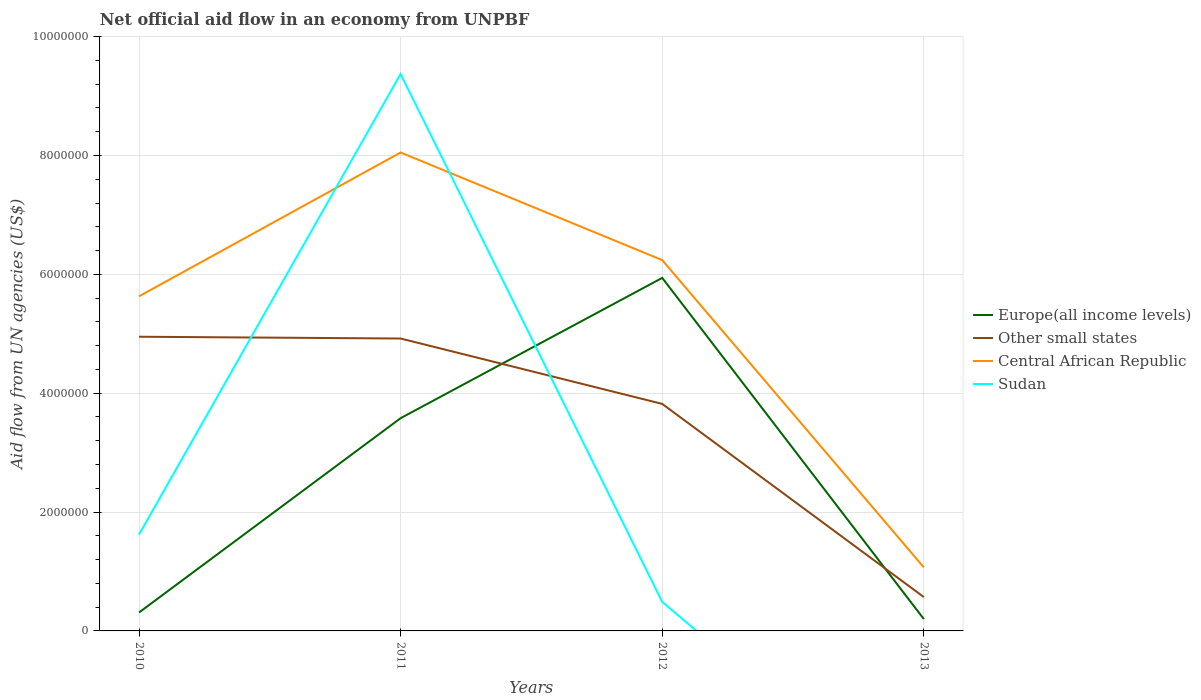Is the number of lines equal to the number of legend labels?
Ensure brevity in your answer.  No. What is the total net official aid flow in Other small states in the graph?
Ensure brevity in your answer.  1.13e+06. What is the difference between the highest and the second highest net official aid flow in Sudan?
Ensure brevity in your answer.  9.37e+06. What is the difference between the highest and the lowest net official aid flow in Other small states?
Offer a terse response. 3. Is the net official aid flow in Europe(all income levels) strictly greater than the net official aid flow in Sudan over the years?
Offer a terse response. No. Are the values on the major ticks of Y-axis written in scientific E-notation?
Give a very brief answer. No. Where does the legend appear in the graph?
Ensure brevity in your answer.  Center right. How many legend labels are there?
Make the answer very short. 4. What is the title of the graph?
Offer a terse response. Net official aid flow in an economy from UNPBF. Does "Russian Federation" appear as one of the legend labels in the graph?
Provide a succinct answer. No. What is the label or title of the Y-axis?
Provide a short and direct response. Aid flow from UN agencies (US$). What is the Aid flow from UN agencies (US$) of Europe(all income levels) in 2010?
Give a very brief answer. 3.10e+05. What is the Aid flow from UN agencies (US$) in Other small states in 2010?
Keep it short and to the point. 4.95e+06. What is the Aid flow from UN agencies (US$) of Central African Republic in 2010?
Offer a very short reply. 5.63e+06. What is the Aid flow from UN agencies (US$) of Sudan in 2010?
Offer a terse response. 1.62e+06. What is the Aid flow from UN agencies (US$) of Europe(all income levels) in 2011?
Provide a short and direct response. 3.58e+06. What is the Aid flow from UN agencies (US$) in Other small states in 2011?
Your answer should be compact. 4.92e+06. What is the Aid flow from UN agencies (US$) of Central African Republic in 2011?
Offer a very short reply. 8.05e+06. What is the Aid flow from UN agencies (US$) in Sudan in 2011?
Your response must be concise. 9.37e+06. What is the Aid flow from UN agencies (US$) of Europe(all income levels) in 2012?
Your response must be concise. 5.94e+06. What is the Aid flow from UN agencies (US$) of Other small states in 2012?
Provide a short and direct response. 3.82e+06. What is the Aid flow from UN agencies (US$) of Central African Republic in 2012?
Provide a short and direct response. 6.24e+06. What is the Aid flow from UN agencies (US$) in Sudan in 2012?
Keep it short and to the point. 4.90e+05. What is the Aid flow from UN agencies (US$) in Other small states in 2013?
Offer a very short reply. 5.70e+05. What is the Aid flow from UN agencies (US$) of Central African Republic in 2013?
Offer a terse response. 1.07e+06. What is the Aid flow from UN agencies (US$) in Sudan in 2013?
Your answer should be compact. 0. Across all years, what is the maximum Aid flow from UN agencies (US$) of Europe(all income levels)?
Your response must be concise. 5.94e+06. Across all years, what is the maximum Aid flow from UN agencies (US$) of Other small states?
Make the answer very short. 4.95e+06. Across all years, what is the maximum Aid flow from UN agencies (US$) in Central African Republic?
Your answer should be very brief. 8.05e+06. Across all years, what is the maximum Aid flow from UN agencies (US$) in Sudan?
Keep it short and to the point. 9.37e+06. Across all years, what is the minimum Aid flow from UN agencies (US$) of Europe(all income levels)?
Offer a very short reply. 2.00e+05. Across all years, what is the minimum Aid flow from UN agencies (US$) of Other small states?
Keep it short and to the point. 5.70e+05. Across all years, what is the minimum Aid flow from UN agencies (US$) in Central African Republic?
Keep it short and to the point. 1.07e+06. Across all years, what is the minimum Aid flow from UN agencies (US$) in Sudan?
Your answer should be very brief. 0. What is the total Aid flow from UN agencies (US$) of Europe(all income levels) in the graph?
Give a very brief answer. 1.00e+07. What is the total Aid flow from UN agencies (US$) in Other small states in the graph?
Your answer should be very brief. 1.43e+07. What is the total Aid flow from UN agencies (US$) of Central African Republic in the graph?
Give a very brief answer. 2.10e+07. What is the total Aid flow from UN agencies (US$) in Sudan in the graph?
Make the answer very short. 1.15e+07. What is the difference between the Aid flow from UN agencies (US$) of Europe(all income levels) in 2010 and that in 2011?
Your response must be concise. -3.27e+06. What is the difference between the Aid flow from UN agencies (US$) of Other small states in 2010 and that in 2011?
Offer a terse response. 3.00e+04. What is the difference between the Aid flow from UN agencies (US$) of Central African Republic in 2010 and that in 2011?
Offer a terse response. -2.42e+06. What is the difference between the Aid flow from UN agencies (US$) in Sudan in 2010 and that in 2011?
Your response must be concise. -7.75e+06. What is the difference between the Aid flow from UN agencies (US$) in Europe(all income levels) in 2010 and that in 2012?
Offer a very short reply. -5.63e+06. What is the difference between the Aid flow from UN agencies (US$) of Other small states in 2010 and that in 2012?
Ensure brevity in your answer.  1.13e+06. What is the difference between the Aid flow from UN agencies (US$) of Central African Republic in 2010 and that in 2012?
Make the answer very short. -6.10e+05. What is the difference between the Aid flow from UN agencies (US$) of Sudan in 2010 and that in 2012?
Provide a succinct answer. 1.13e+06. What is the difference between the Aid flow from UN agencies (US$) in Other small states in 2010 and that in 2013?
Make the answer very short. 4.38e+06. What is the difference between the Aid flow from UN agencies (US$) in Central African Republic in 2010 and that in 2013?
Ensure brevity in your answer.  4.56e+06. What is the difference between the Aid flow from UN agencies (US$) of Europe(all income levels) in 2011 and that in 2012?
Provide a short and direct response. -2.36e+06. What is the difference between the Aid flow from UN agencies (US$) in Other small states in 2011 and that in 2012?
Your response must be concise. 1.10e+06. What is the difference between the Aid flow from UN agencies (US$) of Central African Republic in 2011 and that in 2012?
Give a very brief answer. 1.81e+06. What is the difference between the Aid flow from UN agencies (US$) in Sudan in 2011 and that in 2012?
Your response must be concise. 8.88e+06. What is the difference between the Aid flow from UN agencies (US$) in Europe(all income levels) in 2011 and that in 2013?
Make the answer very short. 3.38e+06. What is the difference between the Aid flow from UN agencies (US$) in Other small states in 2011 and that in 2013?
Make the answer very short. 4.35e+06. What is the difference between the Aid flow from UN agencies (US$) in Central African Republic in 2011 and that in 2013?
Your answer should be compact. 6.98e+06. What is the difference between the Aid flow from UN agencies (US$) of Europe(all income levels) in 2012 and that in 2013?
Ensure brevity in your answer.  5.74e+06. What is the difference between the Aid flow from UN agencies (US$) in Other small states in 2012 and that in 2013?
Your response must be concise. 3.25e+06. What is the difference between the Aid flow from UN agencies (US$) in Central African Republic in 2012 and that in 2013?
Your answer should be compact. 5.17e+06. What is the difference between the Aid flow from UN agencies (US$) of Europe(all income levels) in 2010 and the Aid flow from UN agencies (US$) of Other small states in 2011?
Your answer should be compact. -4.61e+06. What is the difference between the Aid flow from UN agencies (US$) of Europe(all income levels) in 2010 and the Aid flow from UN agencies (US$) of Central African Republic in 2011?
Your answer should be very brief. -7.74e+06. What is the difference between the Aid flow from UN agencies (US$) in Europe(all income levels) in 2010 and the Aid flow from UN agencies (US$) in Sudan in 2011?
Your response must be concise. -9.06e+06. What is the difference between the Aid flow from UN agencies (US$) of Other small states in 2010 and the Aid flow from UN agencies (US$) of Central African Republic in 2011?
Provide a short and direct response. -3.10e+06. What is the difference between the Aid flow from UN agencies (US$) in Other small states in 2010 and the Aid flow from UN agencies (US$) in Sudan in 2011?
Keep it short and to the point. -4.42e+06. What is the difference between the Aid flow from UN agencies (US$) in Central African Republic in 2010 and the Aid flow from UN agencies (US$) in Sudan in 2011?
Ensure brevity in your answer.  -3.74e+06. What is the difference between the Aid flow from UN agencies (US$) of Europe(all income levels) in 2010 and the Aid flow from UN agencies (US$) of Other small states in 2012?
Provide a succinct answer. -3.51e+06. What is the difference between the Aid flow from UN agencies (US$) in Europe(all income levels) in 2010 and the Aid flow from UN agencies (US$) in Central African Republic in 2012?
Your answer should be very brief. -5.93e+06. What is the difference between the Aid flow from UN agencies (US$) of Europe(all income levels) in 2010 and the Aid flow from UN agencies (US$) of Sudan in 2012?
Keep it short and to the point. -1.80e+05. What is the difference between the Aid flow from UN agencies (US$) of Other small states in 2010 and the Aid flow from UN agencies (US$) of Central African Republic in 2012?
Keep it short and to the point. -1.29e+06. What is the difference between the Aid flow from UN agencies (US$) of Other small states in 2010 and the Aid flow from UN agencies (US$) of Sudan in 2012?
Your answer should be very brief. 4.46e+06. What is the difference between the Aid flow from UN agencies (US$) of Central African Republic in 2010 and the Aid flow from UN agencies (US$) of Sudan in 2012?
Provide a succinct answer. 5.14e+06. What is the difference between the Aid flow from UN agencies (US$) of Europe(all income levels) in 2010 and the Aid flow from UN agencies (US$) of Central African Republic in 2013?
Provide a short and direct response. -7.60e+05. What is the difference between the Aid flow from UN agencies (US$) of Other small states in 2010 and the Aid flow from UN agencies (US$) of Central African Republic in 2013?
Your response must be concise. 3.88e+06. What is the difference between the Aid flow from UN agencies (US$) in Europe(all income levels) in 2011 and the Aid flow from UN agencies (US$) in Central African Republic in 2012?
Your response must be concise. -2.66e+06. What is the difference between the Aid flow from UN agencies (US$) of Europe(all income levels) in 2011 and the Aid flow from UN agencies (US$) of Sudan in 2012?
Ensure brevity in your answer.  3.09e+06. What is the difference between the Aid flow from UN agencies (US$) of Other small states in 2011 and the Aid flow from UN agencies (US$) of Central African Republic in 2012?
Offer a terse response. -1.32e+06. What is the difference between the Aid flow from UN agencies (US$) in Other small states in 2011 and the Aid flow from UN agencies (US$) in Sudan in 2012?
Your answer should be very brief. 4.43e+06. What is the difference between the Aid flow from UN agencies (US$) in Central African Republic in 2011 and the Aid flow from UN agencies (US$) in Sudan in 2012?
Keep it short and to the point. 7.56e+06. What is the difference between the Aid flow from UN agencies (US$) of Europe(all income levels) in 2011 and the Aid flow from UN agencies (US$) of Other small states in 2013?
Offer a very short reply. 3.01e+06. What is the difference between the Aid flow from UN agencies (US$) of Europe(all income levels) in 2011 and the Aid flow from UN agencies (US$) of Central African Republic in 2013?
Make the answer very short. 2.51e+06. What is the difference between the Aid flow from UN agencies (US$) in Other small states in 2011 and the Aid flow from UN agencies (US$) in Central African Republic in 2013?
Your response must be concise. 3.85e+06. What is the difference between the Aid flow from UN agencies (US$) of Europe(all income levels) in 2012 and the Aid flow from UN agencies (US$) of Other small states in 2013?
Your response must be concise. 5.37e+06. What is the difference between the Aid flow from UN agencies (US$) of Europe(all income levels) in 2012 and the Aid flow from UN agencies (US$) of Central African Republic in 2013?
Offer a very short reply. 4.87e+06. What is the difference between the Aid flow from UN agencies (US$) in Other small states in 2012 and the Aid flow from UN agencies (US$) in Central African Republic in 2013?
Keep it short and to the point. 2.75e+06. What is the average Aid flow from UN agencies (US$) of Europe(all income levels) per year?
Provide a succinct answer. 2.51e+06. What is the average Aid flow from UN agencies (US$) of Other small states per year?
Your answer should be compact. 3.56e+06. What is the average Aid flow from UN agencies (US$) in Central African Republic per year?
Provide a succinct answer. 5.25e+06. What is the average Aid flow from UN agencies (US$) in Sudan per year?
Give a very brief answer. 2.87e+06. In the year 2010, what is the difference between the Aid flow from UN agencies (US$) of Europe(all income levels) and Aid flow from UN agencies (US$) of Other small states?
Make the answer very short. -4.64e+06. In the year 2010, what is the difference between the Aid flow from UN agencies (US$) in Europe(all income levels) and Aid flow from UN agencies (US$) in Central African Republic?
Your answer should be very brief. -5.32e+06. In the year 2010, what is the difference between the Aid flow from UN agencies (US$) of Europe(all income levels) and Aid flow from UN agencies (US$) of Sudan?
Offer a terse response. -1.31e+06. In the year 2010, what is the difference between the Aid flow from UN agencies (US$) in Other small states and Aid flow from UN agencies (US$) in Central African Republic?
Your answer should be compact. -6.80e+05. In the year 2010, what is the difference between the Aid flow from UN agencies (US$) in Other small states and Aid flow from UN agencies (US$) in Sudan?
Provide a succinct answer. 3.33e+06. In the year 2010, what is the difference between the Aid flow from UN agencies (US$) of Central African Republic and Aid flow from UN agencies (US$) of Sudan?
Offer a terse response. 4.01e+06. In the year 2011, what is the difference between the Aid flow from UN agencies (US$) of Europe(all income levels) and Aid flow from UN agencies (US$) of Other small states?
Offer a very short reply. -1.34e+06. In the year 2011, what is the difference between the Aid flow from UN agencies (US$) in Europe(all income levels) and Aid flow from UN agencies (US$) in Central African Republic?
Give a very brief answer. -4.47e+06. In the year 2011, what is the difference between the Aid flow from UN agencies (US$) in Europe(all income levels) and Aid flow from UN agencies (US$) in Sudan?
Ensure brevity in your answer.  -5.79e+06. In the year 2011, what is the difference between the Aid flow from UN agencies (US$) in Other small states and Aid flow from UN agencies (US$) in Central African Republic?
Give a very brief answer. -3.13e+06. In the year 2011, what is the difference between the Aid flow from UN agencies (US$) in Other small states and Aid flow from UN agencies (US$) in Sudan?
Ensure brevity in your answer.  -4.45e+06. In the year 2011, what is the difference between the Aid flow from UN agencies (US$) of Central African Republic and Aid flow from UN agencies (US$) of Sudan?
Provide a succinct answer. -1.32e+06. In the year 2012, what is the difference between the Aid flow from UN agencies (US$) of Europe(all income levels) and Aid flow from UN agencies (US$) of Other small states?
Your answer should be very brief. 2.12e+06. In the year 2012, what is the difference between the Aid flow from UN agencies (US$) in Europe(all income levels) and Aid flow from UN agencies (US$) in Sudan?
Offer a terse response. 5.45e+06. In the year 2012, what is the difference between the Aid flow from UN agencies (US$) of Other small states and Aid flow from UN agencies (US$) of Central African Republic?
Offer a terse response. -2.42e+06. In the year 2012, what is the difference between the Aid flow from UN agencies (US$) in Other small states and Aid flow from UN agencies (US$) in Sudan?
Offer a very short reply. 3.33e+06. In the year 2012, what is the difference between the Aid flow from UN agencies (US$) of Central African Republic and Aid flow from UN agencies (US$) of Sudan?
Make the answer very short. 5.75e+06. In the year 2013, what is the difference between the Aid flow from UN agencies (US$) of Europe(all income levels) and Aid flow from UN agencies (US$) of Other small states?
Your answer should be very brief. -3.70e+05. In the year 2013, what is the difference between the Aid flow from UN agencies (US$) in Europe(all income levels) and Aid flow from UN agencies (US$) in Central African Republic?
Make the answer very short. -8.70e+05. In the year 2013, what is the difference between the Aid flow from UN agencies (US$) in Other small states and Aid flow from UN agencies (US$) in Central African Republic?
Your response must be concise. -5.00e+05. What is the ratio of the Aid flow from UN agencies (US$) of Europe(all income levels) in 2010 to that in 2011?
Offer a terse response. 0.09. What is the ratio of the Aid flow from UN agencies (US$) in Other small states in 2010 to that in 2011?
Ensure brevity in your answer.  1.01. What is the ratio of the Aid flow from UN agencies (US$) of Central African Republic in 2010 to that in 2011?
Offer a very short reply. 0.7. What is the ratio of the Aid flow from UN agencies (US$) of Sudan in 2010 to that in 2011?
Your response must be concise. 0.17. What is the ratio of the Aid flow from UN agencies (US$) in Europe(all income levels) in 2010 to that in 2012?
Make the answer very short. 0.05. What is the ratio of the Aid flow from UN agencies (US$) in Other small states in 2010 to that in 2012?
Offer a very short reply. 1.3. What is the ratio of the Aid flow from UN agencies (US$) of Central African Republic in 2010 to that in 2012?
Your answer should be very brief. 0.9. What is the ratio of the Aid flow from UN agencies (US$) of Sudan in 2010 to that in 2012?
Offer a terse response. 3.31. What is the ratio of the Aid flow from UN agencies (US$) in Europe(all income levels) in 2010 to that in 2013?
Provide a short and direct response. 1.55. What is the ratio of the Aid flow from UN agencies (US$) in Other small states in 2010 to that in 2013?
Keep it short and to the point. 8.68. What is the ratio of the Aid flow from UN agencies (US$) in Central African Republic in 2010 to that in 2013?
Keep it short and to the point. 5.26. What is the ratio of the Aid flow from UN agencies (US$) in Europe(all income levels) in 2011 to that in 2012?
Offer a terse response. 0.6. What is the ratio of the Aid flow from UN agencies (US$) of Other small states in 2011 to that in 2012?
Keep it short and to the point. 1.29. What is the ratio of the Aid flow from UN agencies (US$) of Central African Republic in 2011 to that in 2012?
Keep it short and to the point. 1.29. What is the ratio of the Aid flow from UN agencies (US$) of Sudan in 2011 to that in 2012?
Provide a short and direct response. 19.12. What is the ratio of the Aid flow from UN agencies (US$) in Other small states in 2011 to that in 2013?
Your answer should be very brief. 8.63. What is the ratio of the Aid flow from UN agencies (US$) in Central African Republic in 2011 to that in 2013?
Keep it short and to the point. 7.52. What is the ratio of the Aid flow from UN agencies (US$) of Europe(all income levels) in 2012 to that in 2013?
Provide a short and direct response. 29.7. What is the ratio of the Aid flow from UN agencies (US$) in Other small states in 2012 to that in 2013?
Provide a short and direct response. 6.7. What is the ratio of the Aid flow from UN agencies (US$) in Central African Republic in 2012 to that in 2013?
Keep it short and to the point. 5.83. What is the difference between the highest and the second highest Aid flow from UN agencies (US$) in Europe(all income levels)?
Keep it short and to the point. 2.36e+06. What is the difference between the highest and the second highest Aid flow from UN agencies (US$) in Central African Republic?
Keep it short and to the point. 1.81e+06. What is the difference between the highest and the second highest Aid flow from UN agencies (US$) of Sudan?
Provide a short and direct response. 7.75e+06. What is the difference between the highest and the lowest Aid flow from UN agencies (US$) in Europe(all income levels)?
Offer a very short reply. 5.74e+06. What is the difference between the highest and the lowest Aid flow from UN agencies (US$) in Other small states?
Keep it short and to the point. 4.38e+06. What is the difference between the highest and the lowest Aid flow from UN agencies (US$) of Central African Republic?
Offer a very short reply. 6.98e+06. What is the difference between the highest and the lowest Aid flow from UN agencies (US$) of Sudan?
Provide a succinct answer. 9.37e+06. 